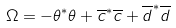Convert formula to latex. <formula><loc_0><loc_0><loc_500><loc_500>\Omega = - \theta ^ { * } \theta + \overline { c } ^ { * } \overline { c } + \overline { d } ^ { * } \overline { d }</formula> 